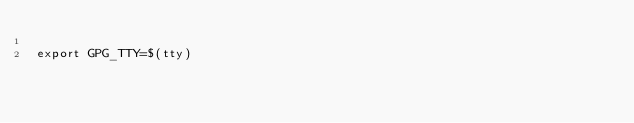Convert code to text. <code><loc_0><loc_0><loc_500><loc_500><_Bash_>
export GPG_TTY=$(tty)
</code> 